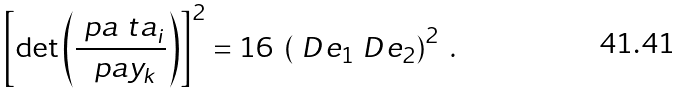<formula> <loc_0><loc_0><loc_500><loc_500>\left [ \det \left ( \frac { \ p a \ t a _ { i } } { \ p a y _ { k } } \right ) \right ] ^ { 2 } = 1 6 \ \left ( \ D e _ { 1 } \ D e _ { 2 } \right ) ^ { 2 } \ .</formula> 